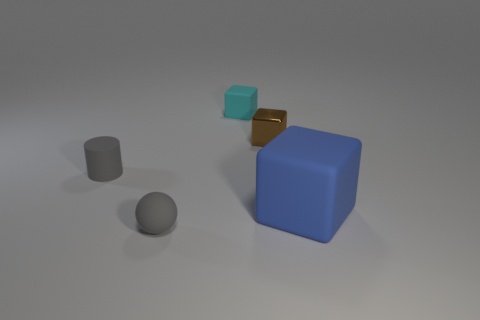Does the blue thing have the same shape as the small metallic thing?
Offer a terse response. Yes. What number of objects are gray things in front of the cylinder or matte cylinders?
Give a very brief answer. 2. Are there the same number of small gray rubber spheres that are on the right side of the small gray sphere and tiny brown metal cubes behind the brown cube?
Give a very brief answer. Yes. There is a thing in front of the big matte object; is its size the same as the rubber block that is behind the blue matte object?
Offer a very short reply. Yes. What number of balls are either tiny things or large things?
Give a very brief answer. 1. How many rubber things are blue spheres or things?
Provide a short and direct response. 4. What is the size of the other blue thing that is the same shape as the tiny shiny object?
Ensure brevity in your answer.  Large. Is there any other thing that has the same size as the brown metallic cube?
Offer a terse response. Yes. There is a cylinder; is its size the same as the matte cube behind the tiny brown shiny block?
Your response must be concise. Yes. The tiny thing that is left of the tiny gray ball has what shape?
Your answer should be compact. Cylinder. 